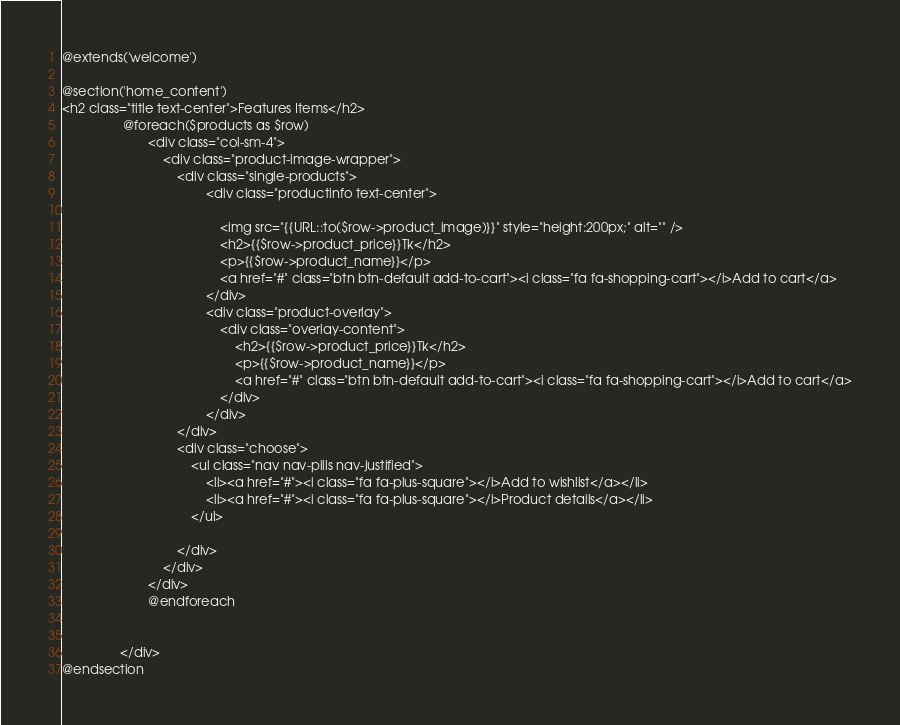<code> <loc_0><loc_0><loc_500><loc_500><_PHP_>@extends('welcome')

@section('home_content')
<h2 class="title text-center">Features Items</h2>
                 @foreach($products as $row)
						<div class="col-sm-4">
							<div class="product-image-wrapper">
								<div class="single-products">
										<div class="productinfo text-center">
										
											<img src="{{URL::to($row->product_image)}}" style="height:200px;" alt="" />
											<h2>{{$row->product_price}}Tk</h2>
											<p>{{$row->product_name}}</p>
											<a href="#" class="btn btn-default add-to-cart"><i class="fa fa-shopping-cart"></i>Add to cart</a>
										</div>
										<div class="product-overlay">
											<div class="overlay-content">
												<h2>{{$row->product_price}}Tk</h2>
												<p>{{$row->product_name}}</p>
												<a href="#" class="btn btn-default add-to-cart"><i class="fa fa-shopping-cart"></i>Add to cart</a>
											</div>
										</div>
								</div>
								<div class="choose">
									<ul class="nav nav-pills nav-justified">
										<li><a href="#"><i class="fa fa-plus-square"></i>Add to wishlist</a></li>
										<li><a href="#"><i class="fa fa-plus-square"></i>Product details</a></li>
									</ul>
								
								</div>
							</div>
						</div>
						@endforeach
								
				
				</div>
@endsection</code> 